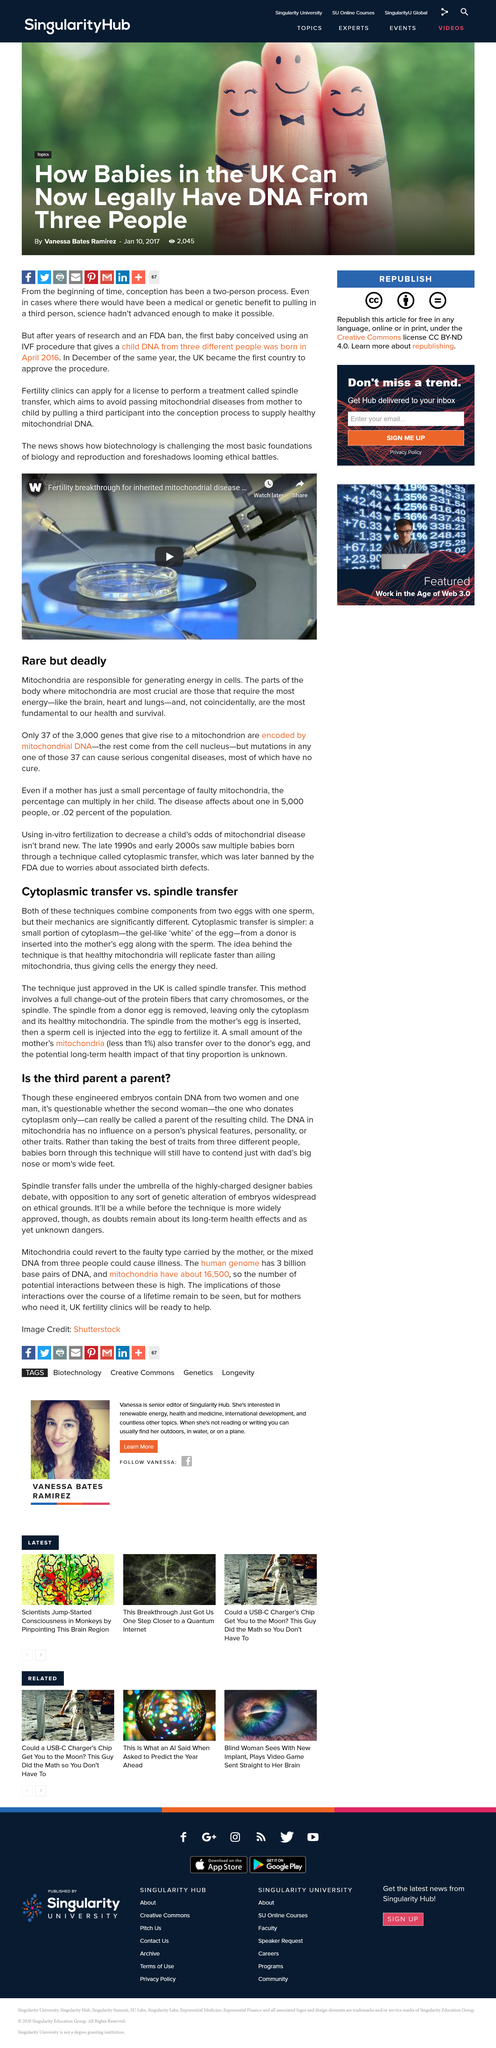Highlight a few significant elements in this photo. Cytoplasmic transfer and spindle transfer are two techniques used in assisted reproduction that combine components from two eggs with one sperm. In cytoplasmic transfer, the cytoplasm of a donor egg is transferred to the recipient egg, while in spindle transfer, the spindle of a donor egg is transferred to the recipient egg. These techniques are used to increase the chances of fertilization and implantation in cases where the recipient's eggs are not viable or there are other fertility issues. In the past, it was typically required for conception to involve two people. The human genome contains a total of 3 billion base pairs of DNA. According to the article "Rare but deadly," mitochondria are responsible for generating energy within cells by converting nutrients into usable energy. Yes, clinics are required to obtain a license in order to undertake spindle transfer procedures. 